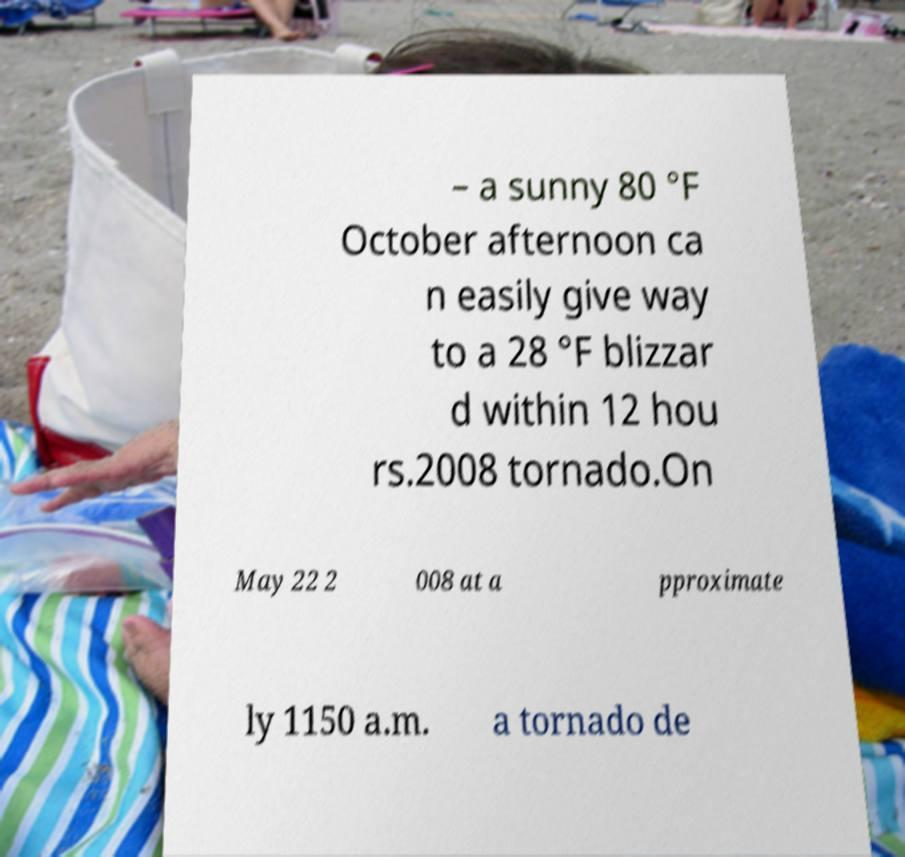I need the written content from this picture converted into text. Can you do that? – a sunny 80 °F October afternoon ca n easily give way to a 28 °F blizzar d within 12 hou rs.2008 tornado.On May 22 2 008 at a pproximate ly 1150 a.m. a tornado de 